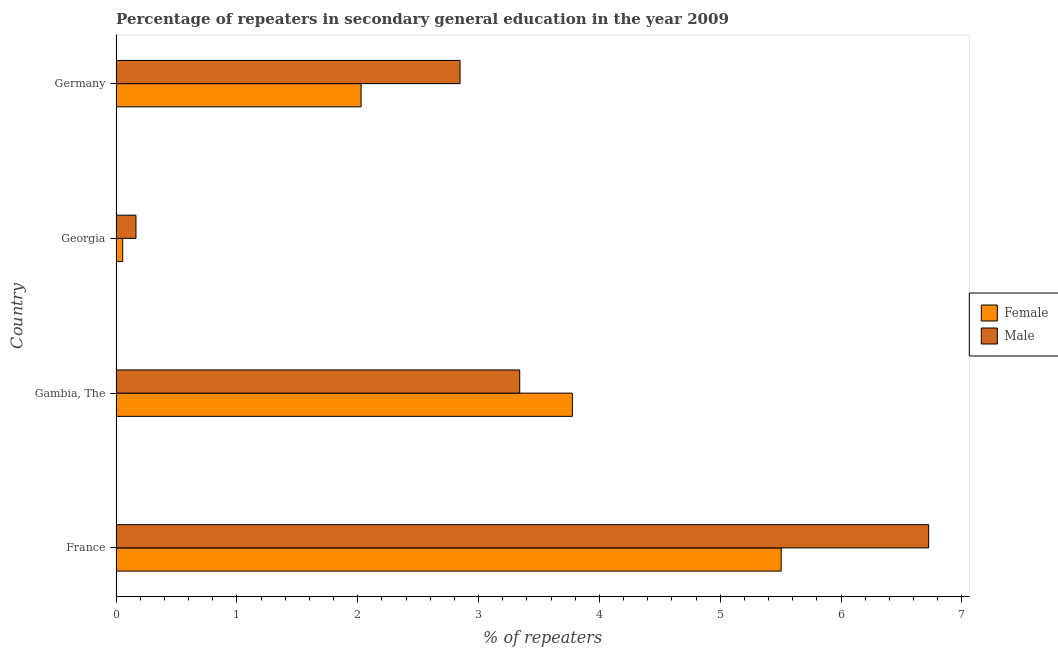How many different coloured bars are there?
Make the answer very short. 2. Are the number of bars per tick equal to the number of legend labels?
Offer a terse response. Yes. Are the number of bars on each tick of the Y-axis equal?
Offer a terse response. Yes. How many bars are there on the 3rd tick from the top?
Ensure brevity in your answer.  2. What is the label of the 1st group of bars from the top?
Your answer should be very brief. Germany. What is the percentage of female repeaters in France?
Make the answer very short. 5.5. Across all countries, what is the maximum percentage of male repeaters?
Provide a succinct answer. 6.72. Across all countries, what is the minimum percentage of female repeaters?
Keep it short and to the point. 0.05. In which country was the percentage of male repeaters minimum?
Your answer should be compact. Georgia. What is the total percentage of male repeaters in the graph?
Give a very brief answer. 13.08. What is the difference between the percentage of female repeaters in Gambia, The and that in Germany?
Your response must be concise. 1.75. What is the difference between the percentage of female repeaters in Georgia and the percentage of male repeaters in Germany?
Your response must be concise. -2.79. What is the average percentage of male repeaters per country?
Offer a very short reply. 3.27. What is the difference between the percentage of female repeaters and percentage of male repeaters in Germany?
Keep it short and to the point. -0.82. What is the ratio of the percentage of female repeaters in France to that in Gambia, The?
Your answer should be compact. 1.46. Is the difference between the percentage of female repeaters in Georgia and Germany greater than the difference between the percentage of male repeaters in Georgia and Germany?
Your response must be concise. Yes. What is the difference between the highest and the second highest percentage of male repeaters?
Offer a terse response. 3.38. What is the difference between the highest and the lowest percentage of male repeaters?
Offer a very short reply. 6.56. What does the 2nd bar from the top in Germany represents?
Offer a very short reply. Female. How many bars are there?
Offer a very short reply. 8. Are all the bars in the graph horizontal?
Provide a succinct answer. Yes. Does the graph contain grids?
Ensure brevity in your answer.  No. What is the title of the graph?
Ensure brevity in your answer.  Percentage of repeaters in secondary general education in the year 2009. What is the label or title of the X-axis?
Make the answer very short. % of repeaters. What is the % of repeaters in Female in France?
Ensure brevity in your answer.  5.5. What is the % of repeaters in Male in France?
Provide a succinct answer. 6.72. What is the % of repeaters in Female in Gambia, The?
Provide a succinct answer. 3.78. What is the % of repeaters in Male in Gambia, The?
Your answer should be compact. 3.34. What is the % of repeaters of Female in Georgia?
Offer a terse response. 0.05. What is the % of repeaters in Male in Georgia?
Your response must be concise. 0.16. What is the % of repeaters of Female in Germany?
Make the answer very short. 2.03. What is the % of repeaters in Male in Germany?
Provide a short and direct response. 2.85. Across all countries, what is the maximum % of repeaters in Female?
Give a very brief answer. 5.5. Across all countries, what is the maximum % of repeaters in Male?
Your answer should be very brief. 6.72. Across all countries, what is the minimum % of repeaters of Female?
Keep it short and to the point. 0.05. Across all countries, what is the minimum % of repeaters of Male?
Offer a terse response. 0.16. What is the total % of repeaters in Female in the graph?
Give a very brief answer. 11.36. What is the total % of repeaters in Male in the graph?
Give a very brief answer. 13.08. What is the difference between the % of repeaters in Female in France and that in Gambia, The?
Provide a succinct answer. 1.73. What is the difference between the % of repeaters in Male in France and that in Gambia, The?
Offer a very short reply. 3.38. What is the difference between the % of repeaters in Female in France and that in Georgia?
Provide a short and direct response. 5.45. What is the difference between the % of repeaters of Male in France and that in Georgia?
Your response must be concise. 6.56. What is the difference between the % of repeaters in Female in France and that in Germany?
Ensure brevity in your answer.  3.48. What is the difference between the % of repeaters of Male in France and that in Germany?
Give a very brief answer. 3.88. What is the difference between the % of repeaters in Female in Gambia, The and that in Georgia?
Ensure brevity in your answer.  3.72. What is the difference between the % of repeaters of Male in Gambia, The and that in Georgia?
Offer a very short reply. 3.18. What is the difference between the % of repeaters in Female in Gambia, The and that in Germany?
Offer a very short reply. 1.75. What is the difference between the % of repeaters of Male in Gambia, The and that in Germany?
Ensure brevity in your answer.  0.49. What is the difference between the % of repeaters in Female in Georgia and that in Germany?
Your answer should be compact. -1.97. What is the difference between the % of repeaters of Male in Georgia and that in Germany?
Offer a very short reply. -2.68. What is the difference between the % of repeaters in Female in France and the % of repeaters in Male in Gambia, The?
Provide a succinct answer. 2.16. What is the difference between the % of repeaters in Female in France and the % of repeaters in Male in Georgia?
Your response must be concise. 5.34. What is the difference between the % of repeaters of Female in France and the % of repeaters of Male in Germany?
Offer a terse response. 2.66. What is the difference between the % of repeaters in Female in Gambia, The and the % of repeaters in Male in Georgia?
Provide a short and direct response. 3.61. What is the difference between the % of repeaters in Female in Gambia, The and the % of repeaters in Male in Germany?
Make the answer very short. 0.93. What is the difference between the % of repeaters of Female in Georgia and the % of repeaters of Male in Germany?
Ensure brevity in your answer.  -2.79. What is the average % of repeaters of Female per country?
Make the answer very short. 2.84. What is the average % of repeaters in Male per country?
Provide a succinct answer. 3.27. What is the difference between the % of repeaters of Female and % of repeaters of Male in France?
Ensure brevity in your answer.  -1.22. What is the difference between the % of repeaters of Female and % of repeaters of Male in Gambia, The?
Make the answer very short. 0.44. What is the difference between the % of repeaters of Female and % of repeaters of Male in Georgia?
Keep it short and to the point. -0.11. What is the difference between the % of repeaters in Female and % of repeaters in Male in Germany?
Provide a succinct answer. -0.82. What is the ratio of the % of repeaters of Female in France to that in Gambia, The?
Make the answer very short. 1.46. What is the ratio of the % of repeaters in Male in France to that in Gambia, The?
Offer a terse response. 2.01. What is the ratio of the % of repeaters of Female in France to that in Georgia?
Ensure brevity in your answer.  101.29. What is the ratio of the % of repeaters of Male in France to that in Georgia?
Provide a short and direct response. 40.94. What is the ratio of the % of repeaters in Female in France to that in Germany?
Your answer should be compact. 2.71. What is the ratio of the % of repeaters in Male in France to that in Germany?
Keep it short and to the point. 2.36. What is the ratio of the % of repeaters in Female in Gambia, The to that in Georgia?
Your answer should be compact. 69.49. What is the ratio of the % of repeaters in Male in Gambia, The to that in Georgia?
Your answer should be compact. 20.33. What is the ratio of the % of repeaters of Female in Gambia, The to that in Germany?
Your answer should be compact. 1.86. What is the ratio of the % of repeaters of Male in Gambia, The to that in Germany?
Offer a very short reply. 1.17. What is the ratio of the % of repeaters in Female in Georgia to that in Germany?
Your response must be concise. 0.03. What is the ratio of the % of repeaters of Male in Georgia to that in Germany?
Ensure brevity in your answer.  0.06. What is the difference between the highest and the second highest % of repeaters in Female?
Keep it short and to the point. 1.73. What is the difference between the highest and the second highest % of repeaters of Male?
Your response must be concise. 3.38. What is the difference between the highest and the lowest % of repeaters in Female?
Provide a succinct answer. 5.45. What is the difference between the highest and the lowest % of repeaters of Male?
Keep it short and to the point. 6.56. 